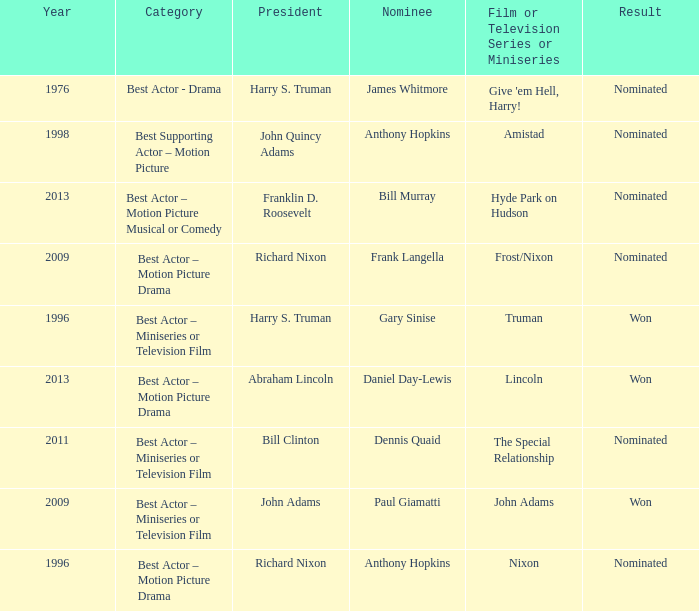What was the result of Frank Langella? Nominated. 